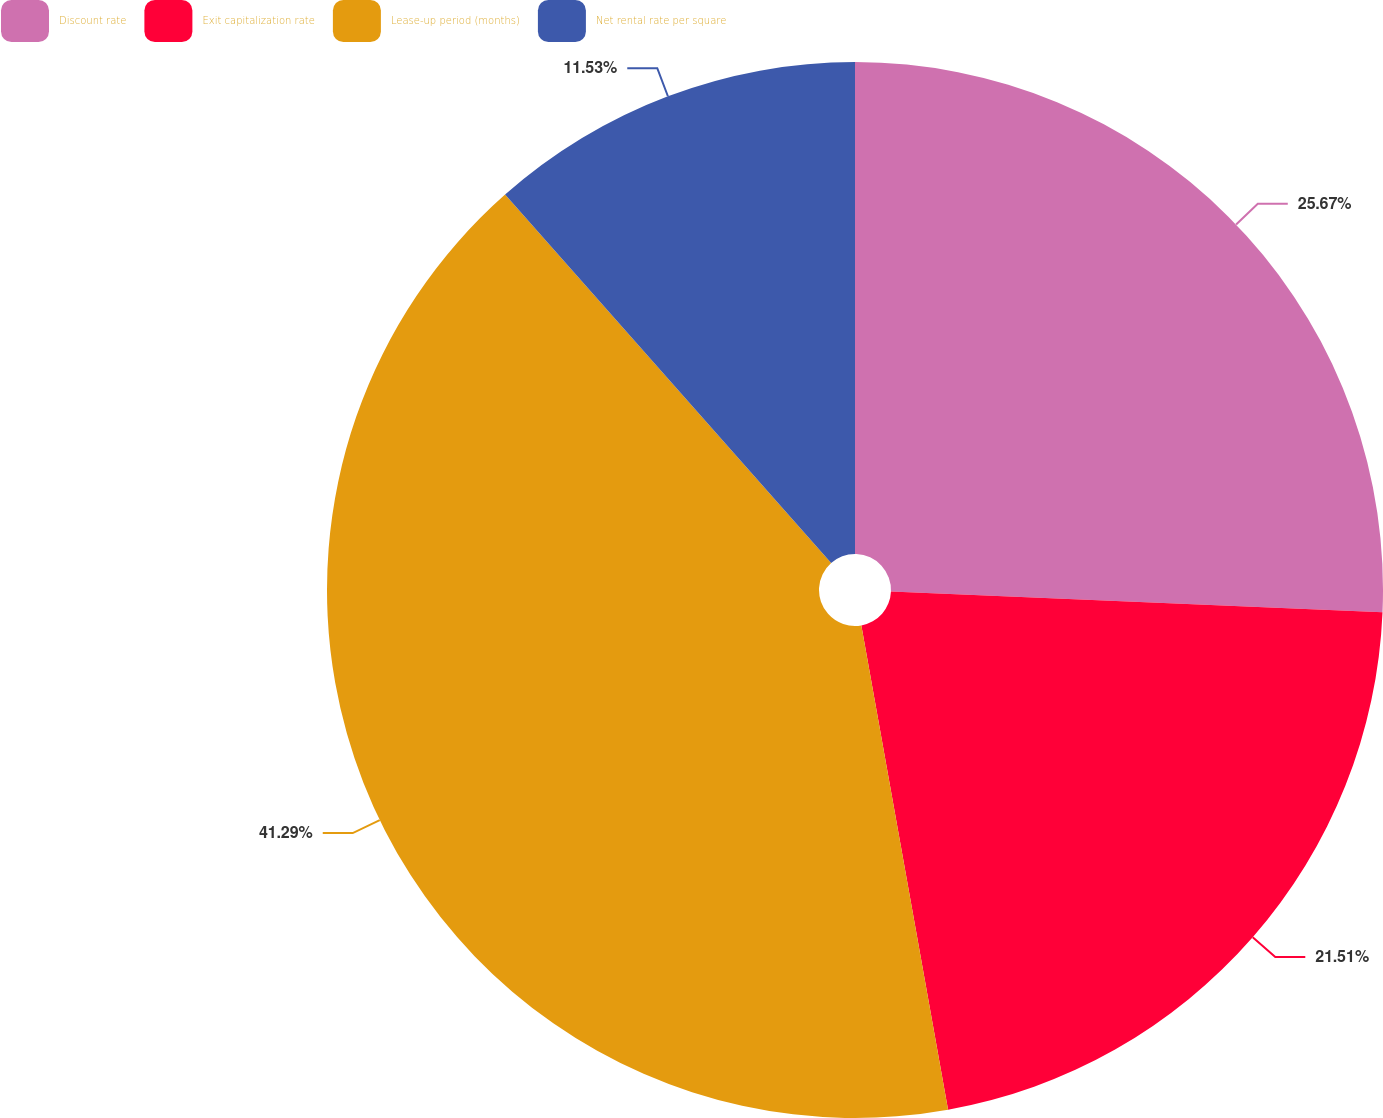Convert chart to OTSL. <chart><loc_0><loc_0><loc_500><loc_500><pie_chart><fcel>Discount rate<fcel>Exit capitalization rate<fcel>Lease-up period (months)<fcel>Net rental rate per square<nl><fcel>25.67%<fcel>21.51%<fcel>41.29%<fcel>11.53%<nl></chart> 